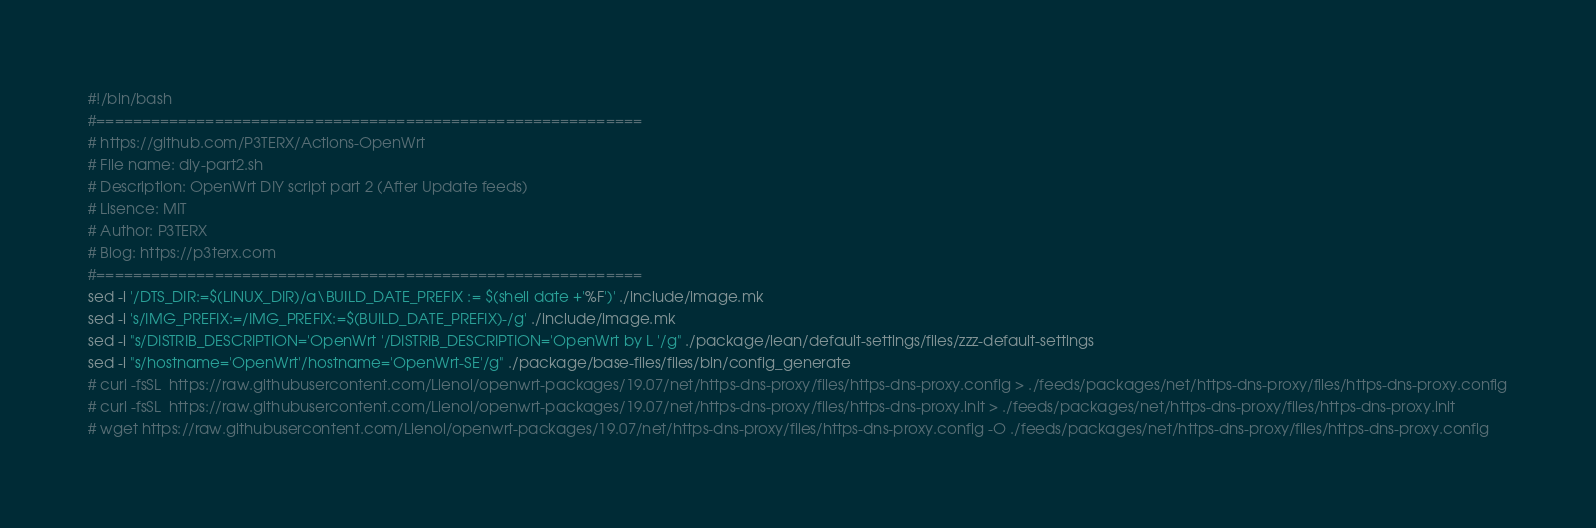<code> <loc_0><loc_0><loc_500><loc_500><_Bash_>#!/bin/bash
#============================================================
# https://github.com/P3TERX/Actions-OpenWrt
# File name: diy-part2.sh
# Description: OpenWrt DIY script part 2 (After Update feeds)
# Lisence: MIT
# Author: P3TERX
# Blog: https://p3terx.com
#============================================================
sed -i '/DTS_DIR:=$(LINUX_DIR)/a\BUILD_DATE_PREFIX := $(shell date +'%F')' ./include/image.mk
sed -i 's/IMG_PREFIX:=/IMG_PREFIX:=$(BUILD_DATE_PREFIX)-/g' ./include/image.mk
sed -i "s/DISTRIB_DESCRIPTION='OpenWrt '/DISTRIB_DESCRIPTION='OpenWrt by L '/g" ./package/lean/default-settings/files/zzz-default-settings
sed -i "s/hostname='OpenWrt'/hostname='OpenWrt-SE'/g" ./package/base-files/files/bin/config_generate
# curl -fsSL  https://raw.githubusercontent.com/Lienol/openwrt-packages/19.07/net/https-dns-proxy/files/https-dns-proxy.config > ./feeds/packages/net/https-dns-proxy/files/https-dns-proxy.config
# curl -fsSL  https://raw.githubusercontent.com/Lienol/openwrt-packages/19.07/net/https-dns-proxy/files/https-dns-proxy.init > ./feeds/packages/net/https-dns-proxy/files/https-dns-proxy.init
# wget https://raw.githubusercontent.com/Lienol/openwrt-packages/19.07/net/https-dns-proxy/files/https-dns-proxy.config -O ./feeds/packages/net/https-dns-proxy/files/https-dns-proxy.config</code> 